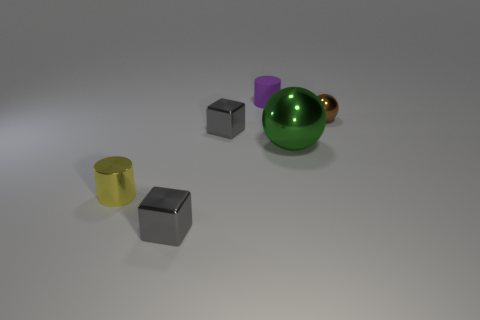Is the shape of the tiny metal object right of the purple thing the same as  the large object?
Keep it short and to the point. Yes. What number of things are cylinders in front of the brown metal ball or small brown rubber spheres?
Give a very brief answer. 1. Is the rubber thing the same shape as the green shiny thing?
Provide a short and direct response. No. How many other objects are there of the same size as the purple cylinder?
Offer a very short reply. 4. What is the color of the large shiny thing?
Your answer should be very brief. Green. What number of tiny objects are either gray cubes or green things?
Ensure brevity in your answer.  2. There is a cylinder that is left of the purple cylinder; does it have the same size as the ball in front of the small brown object?
Your answer should be very brief. No. What is the size of the brown object that is the same shape as the big green thing?
Offer a very short reply. Small. Is the number of purple matte cylinders that are right of the tiny sphere greater than the number of metallic things that are left of the large shiny ball?
Keep it short and to the point. No. What is the object that is in front of the big green thing and to the right of the yellow metal cylinder made of?
Provide a short and direct response. Metal. 